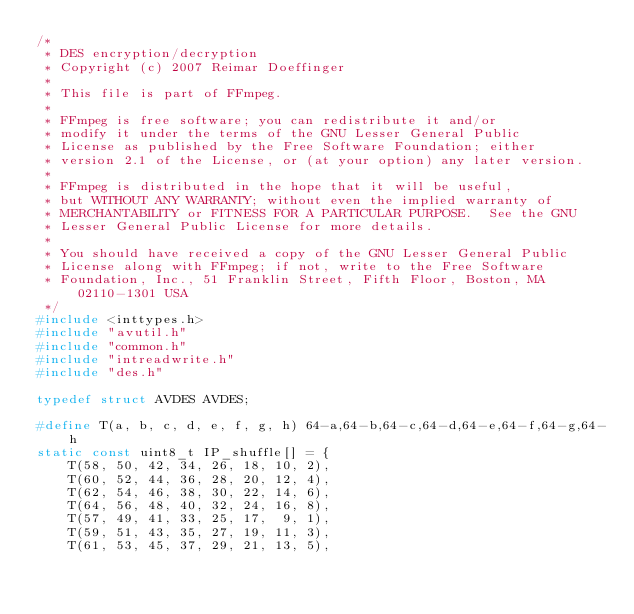<code> <loc_0><loc_0><loc_500><loc_500><_C_>/*
 * DES encryption/decryption
 * Copyright (c) 2007 Reimar Doeffinger
 *
 * This file is part of FFmpeg.
 *
 * FFmpeg is free software; you can redistribute it and/or
 * modify it under the terms of the GNU Lesser General Public
 * License as published by the Free Software Foundation; either
 * version 2.1 of the License, or (at your option) any later version.
 *
 * FFmpeg is distributed in the hope that it will be useful,
 * but WITHOUT ANY WARRANTY; without even the implied warranty of
 * MERCHANTABILITY or FITNESS FOR A PARTICULAR PURPOSE.  See the GNU
 * Lesser General Public License for more details.
 *
 * You should have received a copy of the GNU Lesser General Public
 * License along with FFmpeg; if not, write to the Free Software
 * Foundation, Inc., 51 Franklin Street, Fifth Floor, Boston, MA 02110-1301 USA
 */
#include <inttypes.h>
#include "avutil.h"
#include "common.h"
#include "intreadwrite.h"
#include "des.h"

typedef struct AVDES AVDES;

#define T(a, b, c, d, e, f, g, h) 64-a,64-b,64-c,64-d,64-e,64-f,64-g,64-h
static const uint8_t IP_shuffle[] = {
    T(58, 50, 42, 34, 26, 18, 10, 2),
    T(60, 52, 44, 36, 28, 20, 12, 4),
    T(62, 54, 46, 38, 30, 22, 14, 6),
    T(64, 56, 48, 40, 32, 24, 16, 8),
    T(57, 49, 41, 33, 25, 17,  9, 1),
    T(59, 51, 43, 35, 27, 19, 11, 3),
    T(61, 53, 45, 37, 29, 21, 13, 5),</code> 